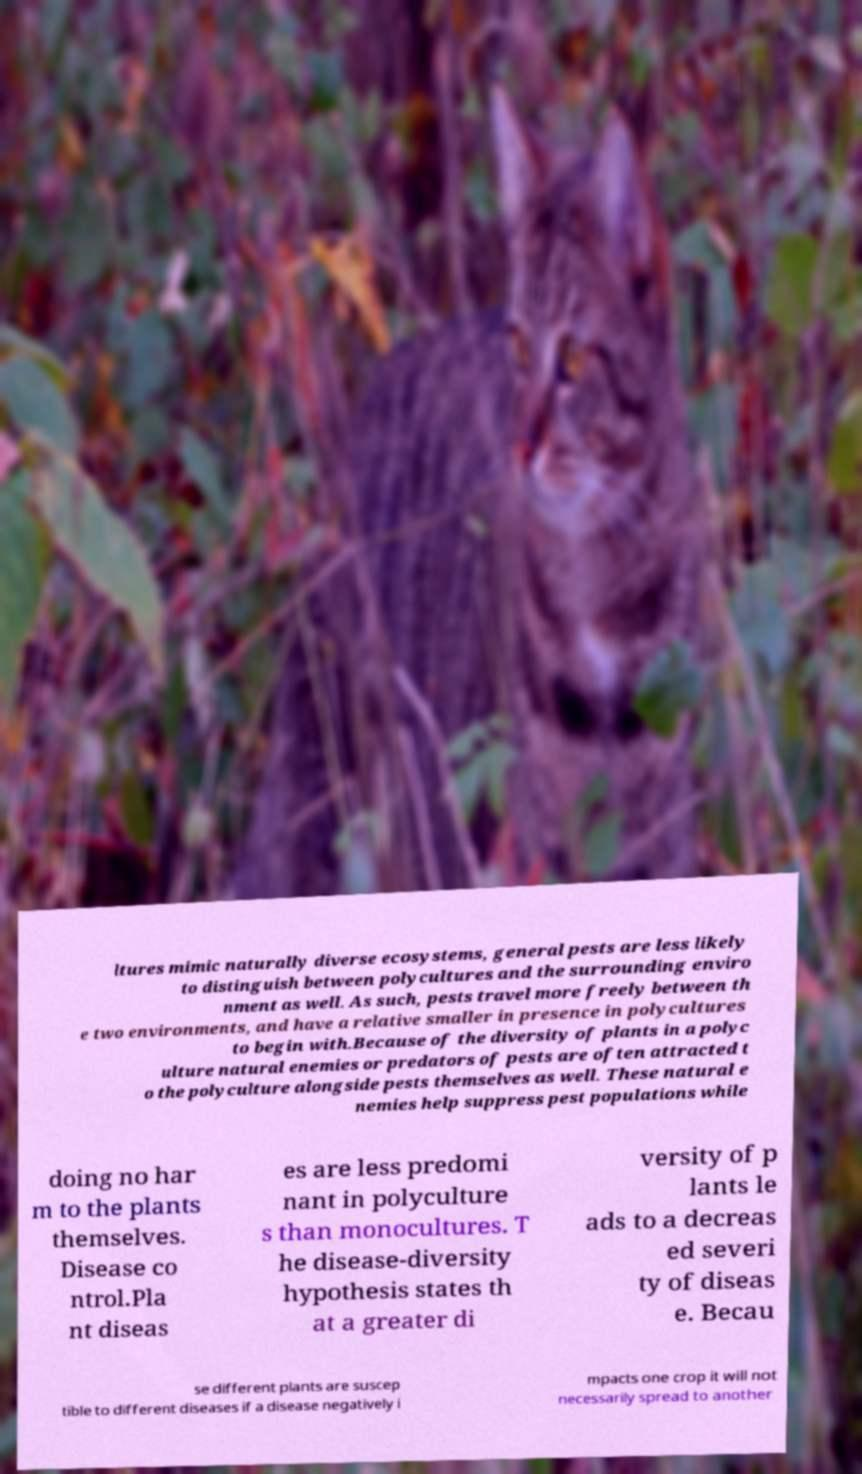For documentation purposes, I need the text within this image transcribed. Could you provide that? ltures mimic naturally diverse ecosystems, general pests are less likely to distinguish between polycultures and the surrounding enviro nment as well. As such, pests travel more freely between th e two environments, and have a relative smaller in presence in polycultures to begin with.Because of the diversity of plants in a polyc ulture natural enemies or predators of pests are often attracted t o the polyculture alongside pests themselves as well. These natural e nemies help suppress pest populations while doing no har m to the plants themselves. Disease co ntrol.Pla nt diseas es are less predomi nant in polyculture s than monocultures. T he disease-diversity hypothesis states th at a greater di versity of p lants le ads to a decreas ed severi ty of diseas e. Becau se different plants are suscep tible to different diseases if a disease negatively i mpacts one crop it will not necessarily spread to another 